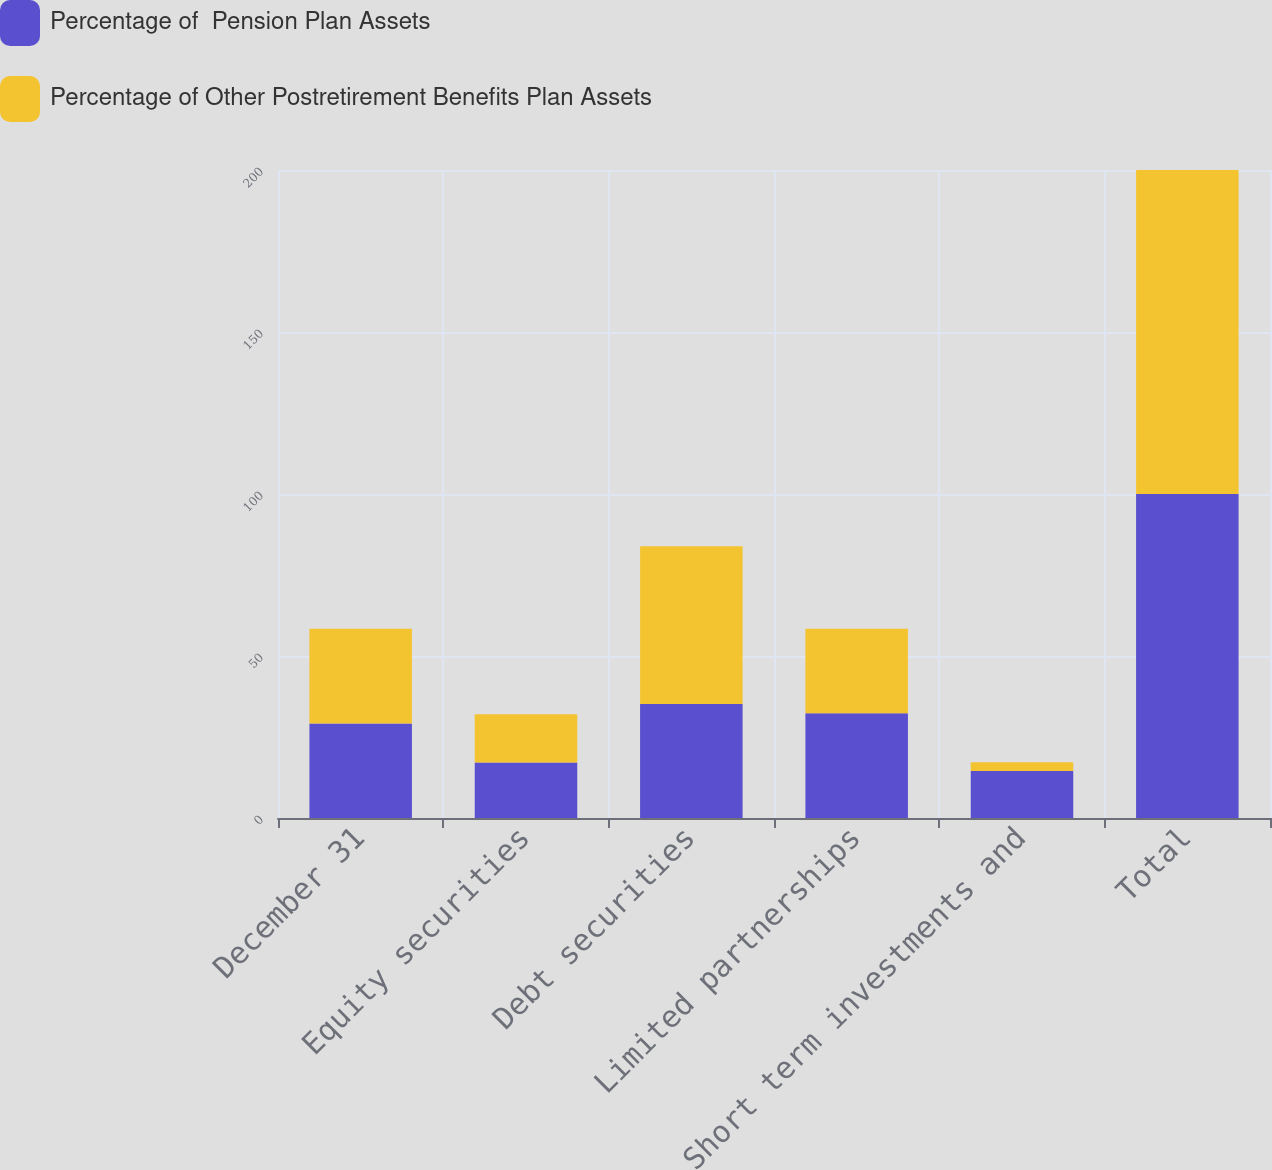Convert chart to OTSL. <chart><loc_0><loc_0><loc_500><loc_500><stacked_bar_chart><ecel><fcel>December 31<fcel>Equity securities<fcel>Debt securities<fcel>Limited partnerships<fcel>Short term investments and<fcel>Total<nl><fcel>Percentage of  Pension Plan Assets<fcel>29.2<fcel>17.1<fcel>35.2<fcel>32.3<fcel>14.5<fcel>100<nl><fcel>Percentage of Other Postretirement Benefits Plan Assets<fcel>29.2<fcel>14.9<fcel>48.7<fcel>26.1<fcel>2.7<fcel>100<nl></chart> 